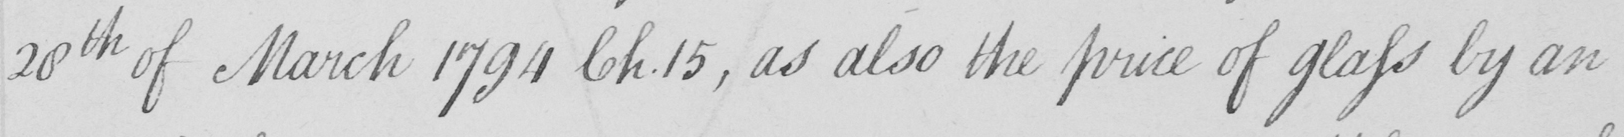What is written in this line of handwriting? 28th of March 1794 Ch.15 , as also the price of glass by an 